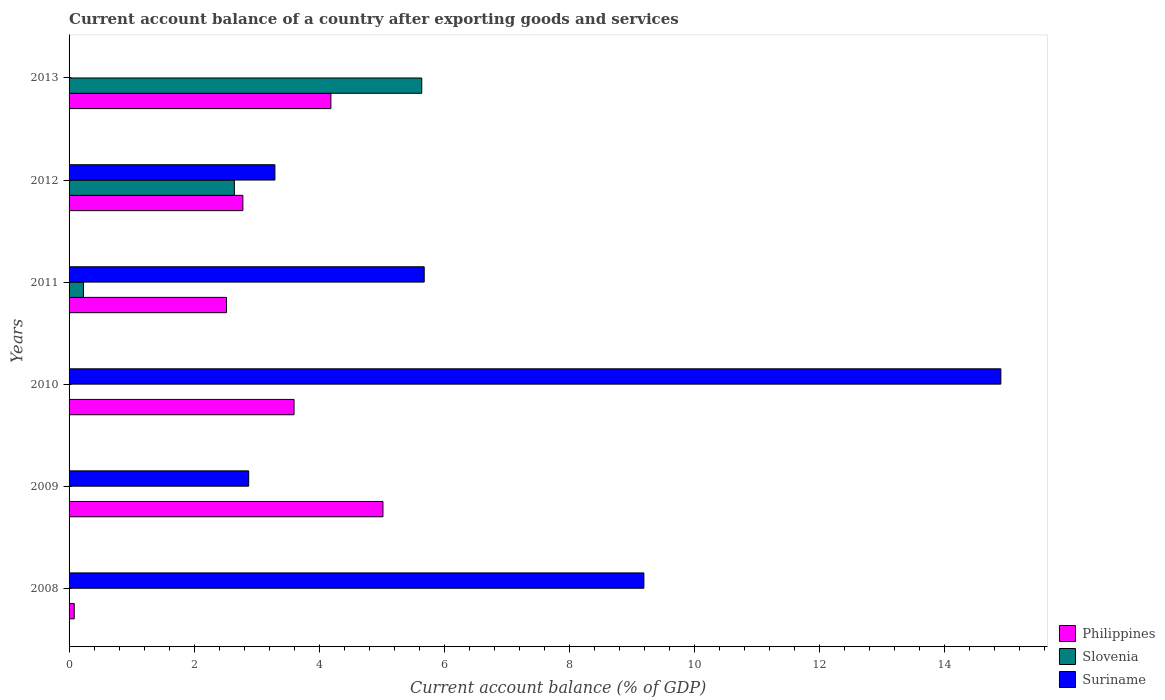How many different coloured bars are there?
Offer a terse response. 3. Are the number of bars on each tick of the Y-axis equal?
Your answer should be compact. No. How many bars are there on the 4th tick from the top?
Provide a short and direct response. 2. How many bars are there on the 5th tick from the bottom?
Your response must be concise. 3. In how many cases, is the number of bars for a given year not equal to the number of legend labels?
Provide a short and direct response. 4. What is the account balance in Slovenia in 2010?
Your answer should be compact. 0. Across all years, what is the maximum account balance in Philippines?
Make the answer very short. 5.02. Across all years, what is the minimum account balance in Philippines?
Provide a succinct answer. 0.08. In which year was the account balance in Suriname maximum?
Keep it short and to the point. 2010. What is the total account balance in Suriname in the graph?
Make the answer very short. 35.93. What is the difference between the account balance in Philippines in 2009 and that in 2012?
Keep it short and to the point. 2.24. What is the difference between the account balance in Philippines in 2009 and the account balance in Suriname in 2011?
Offer a terse response. -0.66. What is the average account balance in Slovenia per year?
Offer a very short reply. 1.42. In the year 2012, what is the difference between the account balance in Philippines and account balance in Slovenia?
Make the answer very short. 0.14. In how many years, is the account balance in Suriname greater than 7.2 %?
Your answer should be very brief. 2. What is the ratio of the account balance in Philippines in 2008 to that in 2009?
Provide a short and direct response. 0.02. Is the account balance in Philippines in 2009 less than that in 2013?
Your answer should be very brief. No. What is the difference between the highest and the second highest account balance in Slovenia?
Keep it short and to the point. 3. What is the difference between the highest and the lowest account balance in Suriname?
Make the answer very short. 14.9. Is the sum of the account balance in Slovenia in 2011 and 2012 greater than the maximum account balance in Philippines across all years?
Make the answer very short. No. How many bars are there?
Offer a terse response. 14. Are all the bars in the graph horizontal?
Your answer should be compact. Yes. What is the difference between two consecutive major ticks on the X-axis?
Provide a short and direct response. 2. What is the title of the graph?
Give a very brief answer. Current account balance of a country after exporting goods and services. Does "Turks and Caicos Islands" appear as one of the legend labels in the graph?
Ensure brevity in your answer.  No. What is the label or title of the X-axis?
Provide a short and direct response. Current account balance (% of GDP). What is the label or title of the Y-axis?
Your answer should be very brief. Years. What is the Current account balance (% of GDP) of Philippines in 2008?
Your answer should be compact. 0.08. What is the Current account balance (% of GDP) in Slovenia in 2008?
Keep it short and to the point. 0. What is the Current account balance (% of GDP) of Suriname in 2008?
Make the answer very short. 9.19. What is the Current account balance (% of GDP) of Philippines in 2009?
Keep it short and to the point. 5.02. What is the Current account balance (% of GDP) in Slovenia in 2009?
Provide a short and direct response. 0. What is the Current account balance (% of GDP) of Suriname in 2009?
Your response must be concise. 2.87. What is the Current account balance (% of GDP) of Philippines in 2010?
Provide a succinct answer. 3.6. What is the Current account balance (% of GDP) of Slovenia in 2010?
Provide a succinct answer. 0. What is the Current account balance (% of GDP) of Suriname in 2010?
Make the answer very short. 14.9. What is the Current account balance (% of GDP) in Philippines in 2011?
Provide a short and direct response. 2.52. What is the Current account balance (% of GDP) of Slovenia in 2011?
Keep it short and to the point. 0.23. What is the Current account balance (% of GDP) of Suriname in 2011?
Provide a short and direct response. 5.68. What is the Current account balance (% of GDP) in Philippines in 2012?
Offer a very short reply. 2.78. What is the Current account balance (% of GDP) of Slovenia in 2012?
Offer a terse response. 2.64. What is the Current account balance (% of GDP) of Suriname in 2012?
Your answer should be very brief. 3.29. What is the Current account balance (% of GDP) in Philippines in 2013?
Make the answer very short. 4.19. What is the Current account balance (% of GDP) in Slovenia in 2013?
Your answer should be compact. 5.64. Across all years, what is the maximum Current account balance (% of GDP) of Philippines?
Ensure brevity in your answer.  5.02. Across all years, what is the maximum Current account balance (% of GDP) in Slovenia?
Ensure brevity in your answer.  5.64. Across all years, what is the maximum Current account balance (% of GDP) of Suriname?
Keep it short and to the point. 14.9. Across all years, what is the minimum Current account balance (% of GDP) of Philippines?
Your answer should be very brief. 0.08. What is the total Current account balance (% of GDP) in Philippines in the graph?
Keep it short and to the point. 18.18. What is the total Current account balance (% of GDP) of Slovenia in the graph?
Provide a succinct answer. 8.51. What is the total Current account balance (% of GDP) of Suriname in the graph?
Offer a very short reply. 35.93. What is the difference between the Current account balance (% of GDP) in Philippines in 2008 and that in 2009?
Give a very brief answer. -4.94. What is the difference between the Current account balance (% of GDP) in Suriname in 2008 and that in 2009?
Your response must be concise. 6.32. What is the difference between the Current account balance (% of GDP) in Philippines in 2008 and that in 2010?
Your answer should be very brief. -3.51. What is the difference between the Current account balance (% of GDP) of Suriname in 2008 and that in 2010?
Your answer should be compact. -5.71. What is the difference between the Current account balance (% of GDP) of Philippines in 2008 and that in 2011?
Offer a terse response. -2.43. What is the difference between the Current account balance (% of GDP) in Suriname in 2008 and that in 2011?
Give a very brief answer. 3.51. What is the difference between the Current account balance (% of GDP) of Philippines in 2008 and that in 2012?
Your answer should be compact. -2.7. What is the difference between the Current account balance (% of GDP) in Suriname in 2008 and that in 2012?
Keep it short and to the point. 5.9. What is the difference between the Current account balance (% of GDP) of Philippines in 2008 and that in 2013?
Keep it short and to the point. -4.1. What is the difference between the Current account balance (% of GDP) of Philippines in 2009 and that in 2010?
Offer a terse response. 1.42. What is the difference between the Current account balance (% of GDP) in Suriname in 2009 and that in 2010?
Keep it short and to the point. -12.03. What is the difference between the Current account balance (% of GDP) in Philippines in 2009 and that in 2011?
Your answer should be compact. 2.5. What is the difference between the Current account balance (% of GDP) in Suriname in 2009 and that in 2011?
Provide a succinct answer. -2.81. What is the difference between the Current account balance (% of GDP) of Philippines in 2009 and that in 2012?
Give a very brief answer. 2.24. What is the difference between the Current account balance (% of GDP) in Suriname in 2009 and that in 2012?
Provide a short and direct response. -0.42. What is the difference between the Current account balance (% of GDP) in Philippines in 2009 and that in 2013?
Provide a succinct answer. 0.83. What is the difference between the Current account balance (% of GDP) of Philippines in 2010 and that in 2011?
Provide a succinct answer. 1.08. What is the difference between the Current account balance (% of GDP) of Suriname in 2010 and that in 2011?
Provide a succinct answer. 9.22. What is the difference between the Current account balance (% of GDP) of Philippines in 2010 and that in 2012?
Offer a very short reply. 0.82. What is the difference between the Current account balance (% of GDP) in Suriname in 2010 and that in 2012?
Provide a short and direct response. 11.61. What is the difference between the Current account balance (% of GDP) of Philippines in 2010 and that in 2013?
Your response must be concise. -0.59. What is the difference between the Current account balance (% of GDP) of Philippines in 2011 and that in 2012?
Offer a very short reply. -0.26. What is the difference between the Current account balance (% of GDP) in Slovenia in 2011 and that in 2012?
Your answer should be compact. -2.41. What is the difference between the Current account balance (% of GDP) of Suriname in 2011 and that in 2012?
Offer a terse response. 2.39. What is the difference between the Current account balance (% of GDP) of Philippines in 2011 and that in 2013?
Keep it short and to the point. -1.67. What is the difference between the Current account balance (% of GDP) of Slovenia in 2011 and that in 2013?
Your answer should be very brief. -5.41. What is the difference between the Current account balance (% of GDP) in Philippines in 2012 and that in 2013?
Offer a very short reply. -1.41. What is the difference between the Current account balance (% of GDP) in Slovenia in 2012 and that in 2013?
Offer a very short reply. -3. What is the difference between the Current account balance (% of GDP) in Philippines in 2008 and the Current account balance (% of GDP) in Suriname in 2009?
Ensure brevity in your answer.  -2.79. What is the difference between the Current account balance (% of GDP) of Philippines in 2008 and the Current account balance (% of GDP) of Suriname in 2010?
Ensure brevity in your answer.  -14.82. What is the difference between the Current account balance (% of GDP) of Philippines in 2008 and the Current account balance (% of GDP) of Slovenia in 2011?
Keep it short and to the point. -0.15. What is the difference between the Current account balance (% of GDP) of Philippines in 2008 and the Current account balance (% of GDP) of Suriname in 2011?
Offer a very short reply. -5.6. What is the difference between the Current account balance (% of GDP) in Philippines in 2008 and the Current account balance (% of GDP) in Slovenia in 2012?
Your answer should be very brief. -2.56. What is the difference between the Current account balance (% of GDP) of Philippines in 2008 and the Current account balance (% of GDP) of Suriname in 2012?
Ensure brevity in your answer.  -3.21. What is the difference between the Current account balance (% of GDP) of Philippines in 2008 and the Current account balance (% of GDP) of Slovenia in 2013?
Your response must be concise. -5.56. What is the difference between the Current account balance (% of GDP) of Philippines in 2009 and the Current account balance (% of GDP) of Suriname in 2010?
Provide a succinct answer. -9.88. What is the difference between the Current account balance (% of GDP) in Philippines in 2009 and the Current account balance (% of GDP) in Slovenia in 2011?
Give a very brief answer. 4.79. What is the difference between the Current account balance (% of GDP) of Philippines in 2009 and the Current account balance (% of GDP) of Suriname in 2011?
Give a very brief answer. -0.66. What is the difference between the Current account balance (% of GDP) in Philippines in 2009 and the Current account balance (% of GDP) in Slovenia in 2012?
Your answer should be very brief. 2.38. What is the difference between the Current account balance (% of GDP) in Philippines in 2009 and the Current account balance (% of GDP) in Suriname in 2012?
Give a very brief answer. 1.73. What is the difference between the Current account balance (% of GDP) in Philippines in 2009 and the Current account balance (% of GDP) in Slovenia in 2013?
Your response must be concise. -0.62. What is the difference between the Current account balance (% of GDP) in Philippines in 2010 and the Current account balance (% of GDP) in Slovenia in 2011?
Provide a short and direct response. 3.37. What is the difference between the Current account balance (% of GDP) of Philippines in 2010 and the Current account balance (% of GDP) of Suriname in 2011?
Your answer should be compact. -2.08. What is the difference between the Current account balance (% of GDP) of Philippines in 2010 and the Current account balance (% of GDP) of Slovenia in 2012?
Provide a succinct answer. 0.95. What is the difference between the Current account balance (% of GDP) in Philippines in 2010 and the Current account balance (% of GDP) in Suriname in 2012?
Offer a terse response. 0.31. What is the difference between the Current account balance (% of GDP) of Philippines in 2010 and the Current account balance (% of GDP) of Slovenia in 2013?
Make the answer very short. -2.04. What is the difference between the Current account balance (% of GDP) in Philippines in 2011 and the Current account balance (% of GDP) in Slovenia in 2012?
Offer a very short reply. -0.13. What is the difference between the Current account balance (% of GDP) of Philippines in 2011 and the Current account balance (% of GDP) of Suriname in 2012?
Provide a succinct answer. -0.77. What is the difference between the Current account balance (% of GDP) of Slovenia in 2011 and the Current account balance (% of GDP) of Suriname in 2012?
Provide a succinct answer. -3.06. What is the difference between the Current account balance (% of GDP) of Philippines in 2011 and the Current account balance (% of GDP) of Slovenia in 2013?
Provide a short and direct response. -3.12. What is the difference between the Current account balance (% of GDP) in Philippines in 2012 and the Current account balance (% of GDP) in Slovenia in 2013?
Offer a very short reply. -2.86. What is the average Current account balance (% of GDP) of Philippines per year?
Make the answer very short. 3.03. What is the average Current account balance (% of GDP) in Slovenia per year?
Give a very brief answer. 1.42. What is the average Current account balance (% of GDP) of Suriname per year?
Provide a short and direct response. 5.99. In the year 2008, what is the difference between the Current account balance (% of GDP) of Philippines and Current account balance (% of GDP) of Suriname?
Ensure brevity in your answer.  -9.11. In the year 2009, what is the difference between the Current account balance (% of GDP) of Philippines and Current account balance (% of GDP) of Suriname?
Offer a very short reply. 2.15. In the year 2010, what is the difference between the Current account balance (% of GDP) in Philippines and Current account balance (% of GDP) in Suriname?
Offer a terse response. -11.3. In the year 2011, what is the difference between the Current account balance (% of GDP) of Philippines and Current account balance (% of GDP) of Slovenia?
Keep it short and to the point. 2.29. In the year 2011, what is the difference between the Current account balance (% of GDP) of Philippines and Current account balance (% of GDP) of Suriname?
Offer a very short reply. -3.16. In the year 2011, what is the difference between the Current account balance (% of GDP) of Slovenia and Current account balance (% of GDP) of Suriname?
Your response must be concise. -5.45. In the year 2012, what is the difference between the Current account balance (% of GDP) of Philippines and Current account balance (% of GDP) of Slovenia?
Make the answer very short. 0.14. In the year 2012, what is the difference between the Current account balance (% of GDP) in Philippines and Current account balance (% of GDP) in Suriname?
Offer a terse response. -0.51. In the year 2012, what is the difference between the Current account balance (% of GDP) of Slovenia and Current account balance (% of GDP) of Suriname?
Provide a succinct answer. -0.65. In the year 2013, what is the difference between the Current account balance (% of GDP) of Philippines and Current account balance (% of GDP) of Slovenia?
Your answer should be very brief. -1.45. What is the ratio of the Current account balance (% of GDP) in Philippines in 2008 to that in 2009?
Keep it short and to the point. 0.02. What is the ratio of the Current account balance (% of GDP) in Suriname in 2008 to that in 2009?
Give a very brief answer. 3.2. What is the ratio of the Current account balance (% of GDP) in Philippines in 2008 to that in 2010?
Give a very brief answer. 0.02. What is the ratio of the Current account balance (% of GDP) in Suriname in 2008 to that in 2010?
Your response must be concise. 0.62. What is the ratio of the Current account balance (% of GDP) of Philippines in 2008 to that in 2011?
Offer a terse response. 0.03. What is the ratio of the Current account balance (% of GDP) of Suriname in 2008 to that in 2011?
Ensure brevity in your answer.  1.62. What is the ratio of the Current account balance (% of GDP) of Philippines in 2008 to that in 2012?
Keep it short and to the point. 0.03. What is the ratio of the Current account balance (% of GDP) in Suriname in 2008 to that in 2012?
Your response must be concise. 2.79. What is the ratio of the Current account balance (% of GDP) in Philippines in 2008 to that in 2013?
Offer a terse response. 0.02. What is the ratio of the Current account balance (% of GDP) of Philippines in 2009 to that in 2010?
Your response must be concise. 1.4. What is the ratio of the Current account balance (% of GDP) of Suriname in 2009 to that in 2010?
Provide a short and direct response. 0.19. What is the ratio of the Current account balance (% of GDP) in Philippines in 2009 to that in 2011?
Your response must be concise. 1.99. What is the ratio of the Current account balance (% of GDP) of Suriname in 2009 to that in 2011?
Give a very brief answer. 0.51. What is the ratio of the Current account balance (% of GDP) in Philippines in 2009 to that in 2012?
Provide a succinct answer. 1.81. What is the ratio of the Current account balance (% of GDP) in Suriname in 2009 to that in 2012?
Give a very brief answer. 0.87. What is the ratio of the Current account balance (% of GDP) of Philippines in 2009 to that in 2013?
Your answer should be compact. 1.2. What is the ratio of the Current account balance (% of GDP) in Philippines in 2010 to that in 2011?
Your response must be concise. 1.43. What is the ratio of the Current account balance (% of GDP) of Suriname in 2010 to that in 2011?
Your answer should be very brief. 2.62. What is the ratio of the Current account balance (% of GDP) in Philippines in 2010 to that in 2012?
Your answer should be compact. 1.29. What is the ratio of the Current account balance (% of GDP) in Suriname in 2010 to that in 2012?
Give a very brief answer. 4.53. What is the ratio of the Current account balance (% of GDP) in Philippines in 2010 to that in 2013?
Give a very brief answer. 0.86. What is the ratio of the Current account balance (% of GDP) in Philippines in 2011 to that in 2012?
Offer a very short reply. 0.91. What is the ratio of the Current account balance (% of GDP) in Slovenia in 2011 to that in 2012?
Your answer should be compact. 0.09. What is the ratio of the Current account balance (% of GDP) of Suriname in 2011 to that in 2012?
Ensure brevity in your answer.  1.73. What is the ratio of the Current account balance (% of GDP) in Philippines in 2011 to that in 2013?
Provide a short and direct response. 0.6. What is the ratio of the Current account balance (% of GDP) of Slovenia in 2011 to that in 2013?
Make the answer very short. 0.04. What is the ratio of the Current account balance (% of GDP) of Philippines in 2012 to that in 2013?
Keep it short and to the point. 0.66. What is the ratio of the Current account balance (% of GDP) of Slovenia in 2012 to that in 2013?
Offer a very short reply. 0.47. What is the difference between the highest and the second highest Current account balance (% of GDP) of Philippines?
Provide a succinct answer. 0.83. What is the difference between the highest and the second highest Current account balance (% of GDP) of Slovenia?
Give a very brief answer. 3. What is the difference between the highest and the second highest Current account balance (% of GDP) in Suriname?
Your response must be concise. 5.71. What is the difference between the highest and the lowest Current account balance (% of GDP) in Philippines?
Keep it short and to the point. 4.94. What is the difference between the highest and the lowest Current account balance (% of GDP) in Slovenia?
Offer a terse response. 5.64. What is the difference between the highest and the lowest Current account balance (% of GDP) in Suriname?
Provide a short and direct response. 14.9. 